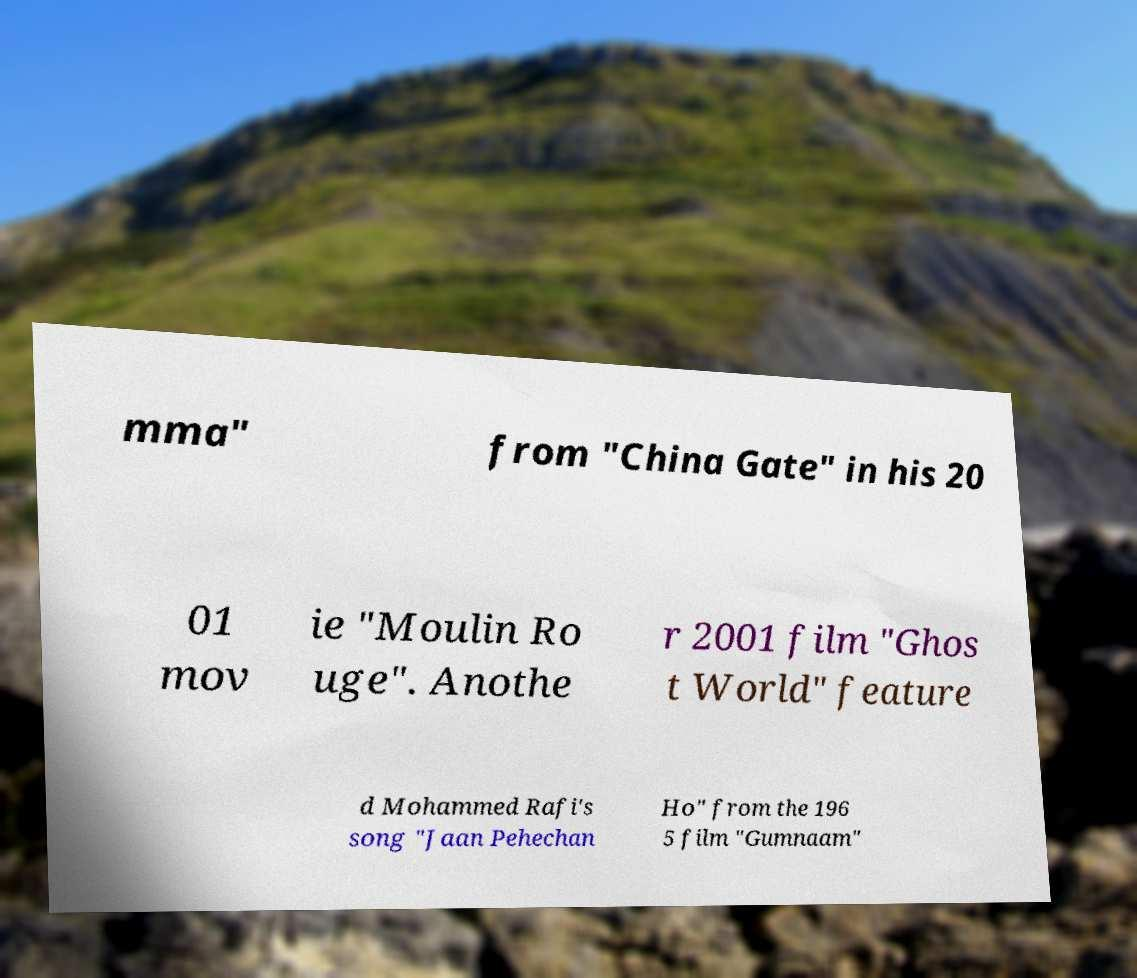Can you read and provide the text displayed in the image?This photo seems to have some interesting text. Can you extract and type it out for me? mma" from "China Gate" in his 20 01 mov ie "Moulin Ro uge". Anothe r 2001 film "Ghos t World" feature d Mohammed Rafi's song "Jaan Pehechan Ho" from the 196 5 film "Gumnaam" 